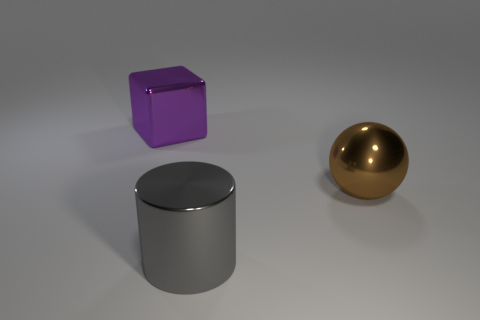Are there more brown things that are on the right side of the brown thing than big spheres?
Ensure brevity in your answer.  No. How many objects are large metallic cylinders or big purple shiny blocks?
Give a very brief answer. 2. What color is the big cylinder?
Make the answer very short. Gray. What number of other objects are the same color as the large metal block?
Provide a short and direct response. 0. Are there any balls on the left side of the big gray shiny cylinder?
Ensure brevity in your answer.  No. What color is the metal object behind the metal thing to the right of the metal object in front of the big brown metallic ball?
Offer a terse response. Purple. What number of large metallic things are left of the brown shiny sphere and in front of the big purple metal block?
Offer a very short reply. 1. What number of cylinders are either large green metallic objects or purple objects?
Your answer should be compact. 0. Is there a big metal object?
Offer a terse response. Yes. There is a gray object that is the same size as the purple cube; what material is it?
Give a very brief answer. Metal. 